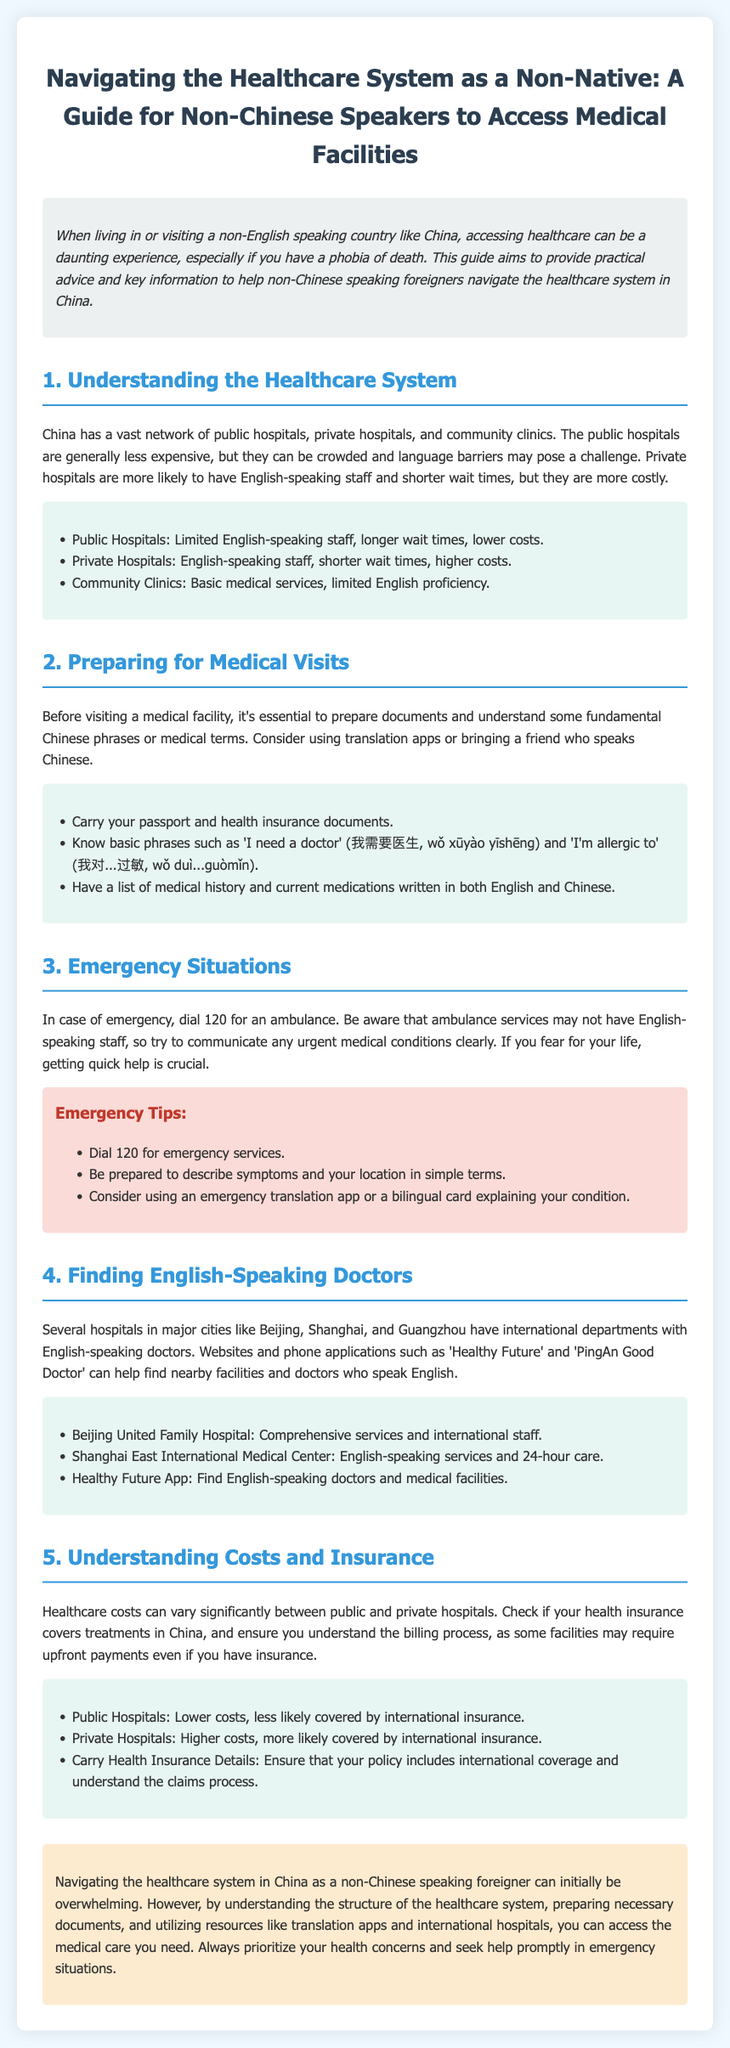What is the title of the document? The title is explicitly stated at the beginning of the document.
Answer: Navigating the Healthcare System as a Non-Native: A Guide for Non-Chinese Speakers to Access Medical Facilities How many main sections are in the document? The document has a numbered list of sections that can be counted.
Answer: 5 What is the emergency number to call in China? The document specifically states the emergency number to dial for an ambulance.
Answer: 120 Which type of hospitals are more likely to have English-speaking staff? The document distinguishes public and private hospitals regarding English-speaking staff.
Answer: Private Hospitals What should you carry before visiting a medical facility? The checklist of items to carry is mentioned in the preparation section.
Answer: Passport and health insurance documents What phrase means 'I need a doctor' in Chinese? The document provides a specific phrase along with its translation.
Answer: 我需要医生 How can one find English-speaking doctors in major cities? The document offers resources for locating doctors through apps and hospitals.
Answer: Healthy Future App What is a key takeaway for emergency situations? The document emphasizes urgent actions in emergency contexts.
Answer: Dial 120 for emergency services 